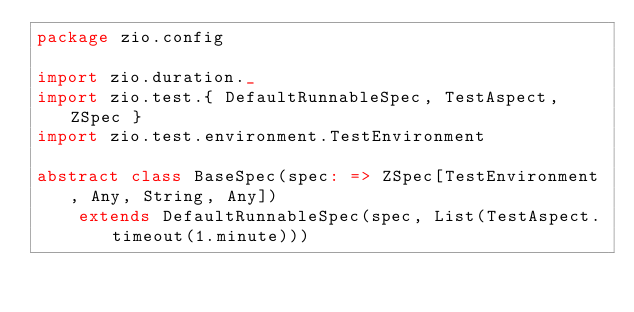<code> <loc_0><loc_0><loc_500><loc_500><_Scala_>package zio.config

import zio.duration._
import zio.test.{ DefaultRunnableSpec, TestAspect, ZSpec }
import zio.test.environment.TestEnvironment

abstract class BaseSpec(spec: => ZSpec[TestEnvironment, Any, String, Any])
    extends DefaultRunnableSpec(spec, List(TestAspect.timeout(1.minute)))
</code> 